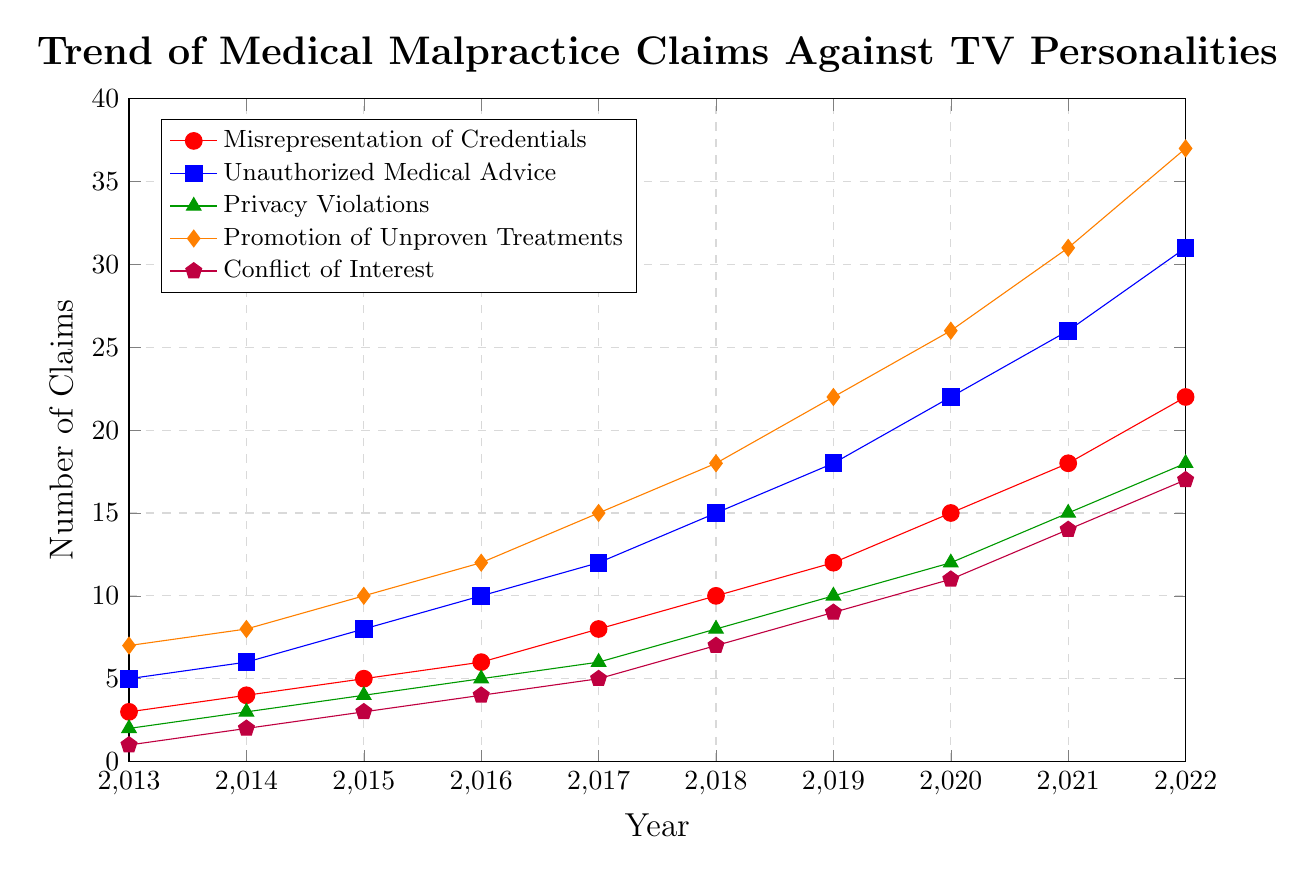What's the trend in the number of claims for Unauthorized Medical Advice from 2013 to 2022? Looking at the blue line representing Unauthorized Medical Advice, it starts at 5 claims in 2013 and steadily increases to 31 claims in 2022. This indicates a rising trend over the decade.
Answer: Rising In 2020, which type of violation had the highest number of claims? Looking at the data points for the year 2020, the highest data point corresponds to the Promotion of Unproven Treatments with 26 claims.
Answer: Promotion of Unproven Treatments How many claims were recorded in total for Misrepresentation of Credentials and Conflict of Interest in the year 2018? For the year 2018, Misrepresentation of Credentials had 10 claims, and Conflict of Interest had 7 claims. Summing them gives 10 + 7 = 17 claims.
Answer: 17 Which type of violation saw the biggest increase in claims from 2013 to 2022? Comparing the start and end points for each type of violation, the Promotion of Unproven Treatments increased from 7 claims in 2013 to 37 claims in 2022. The increase is 37 - 7 = 30 claims, which is the largest among all categories.
Answer: Promotion of Unproven Treatments Between 2015 and 2020, which type of violation experienced a larger increase, Privacy Violations or Conflict of Interest? Privacy Violations increased from 4 claims in 2015 to 12 claims in 2020, an increase of 12 - 4 = 8 claims. Conflict of Interest increased from 3 claims in 2015 to 11 claims in 2020, an increase of 11 - 3 = 8 claims. Both types experienced a similar increase.
Answer: Same increase (8 claims) Which category had the least number of claims in 2013, and what was that number? The lowest data point for 2013 is for Conflict of Interest with 1 claim.
Answer: Conflict of Interest, 1 What is the average number of claims for Unauthorized Medical Advice over the decade? To find the average, sum the claims of Unauthorized Medical Advice from 2013 to 2022 (5 + 6 + 8 + 10 + 12 + 15 + 18 + 22 + 26 + 31 = 153) and divide by the number of years (10). The average is 153 / 10 = 15.3.
Answer: 15.3 In which year did the Misrepresentation of Credentials exceed 10 claims? The red line for Misrepresentation of Credentials first exceeds 10 claims in the year 2019, where it jumps to 12 claims from 10 in 2018.
Answer: 2019 Which type of violation shows the most consistent trend, and what is that trend? The green line for Privacy Violations shows steady incremental increases without sharp fluctuations, indicating a consistent upward trend from 2 claims in 2013 to 18 claims in 2022.
Answer: Privacy Violations, consistent upward trend 